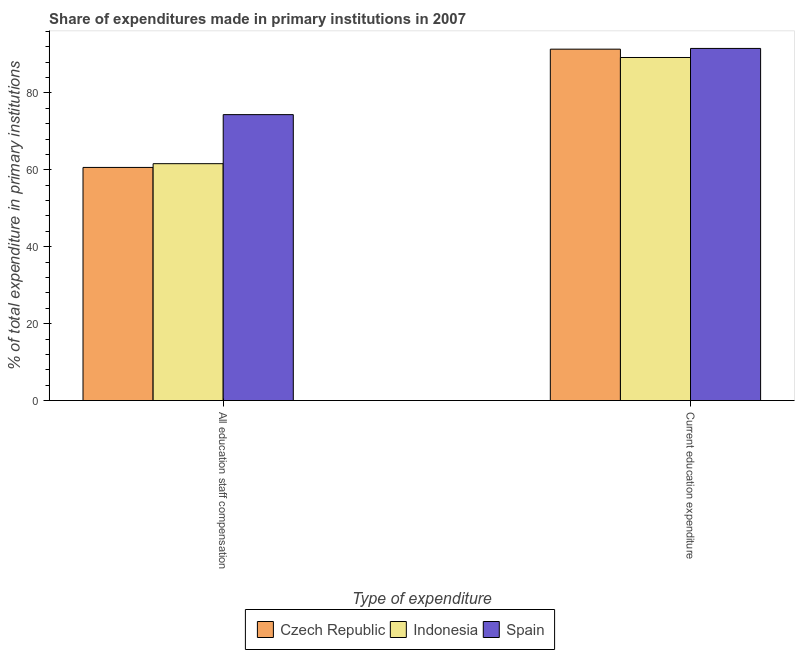Are the number of bars per tick equal to the number of legend labels?
Provide a succinct answer. Yes. How many bars are there on the 1st tick from the right?
Offer a very short reply. 3. What is the label of the 2nd group of bars from the left?
Give a very brief answer. Current education expenditure. What is the expenditure in staff compensation in Czech Republic?
Ensure brevity in your answer.  60.62. Across all countries, what is the maximum expenditure in education?
Provide a short and direct response. 91.57. Across all countries, what is the minimum expenditure in staff compensation?
Your answer should be very brief. 60.62. In which country was the expenditure in staff compensation maximum?
Ensure brevity in your answer.  Spain. In which country was the expenditure in staff compensation minimum?
Offer a very short reply. Czech Republic. What is the total expenditure in staff compensation in the graph?
Give a very brief answer. 196.58. What is the difference between the expenditure in staff compensation in Spain and that in Indonesia?
Your answer should be very brief. 12.75. What is the difference between the expenditure in education in Spain and the expenditure in staff compensation in Czech Republic?
Give a very brief answer. 30.94. What is the average expenditure in staff compensation per country?
Give a very brief answer. 65.53. What is the difference between the expenditure in staff compensation and expenditure in education in Czech Republic?
Your answer should be compact. -30.75. In how many countries, is the expenditure in education greater than 80 %?
Make the answer very short. 3. What is the ratio of the expenditure in staff compensation in Czech Republic to that in Indonesia?
Provide a short and direct response. 0.98. Is the expenditure in staff compensation in Czech Republic less than that in Spain?
Provide a short and direct response. Yes. In how many countries, is the expenditure in education greater than the average expenditure in education taken over all countries?
Provide a short and direct response. 2. How many bars are there?
Keep it short and to the point. 6. How many countries are there in the graph?
Your response must be concise. 3. Does the graph contain any zero values?
Offer a very short reply. No. How many legend labels are there?
Make the answer very short. 3. What is the title of the graph?
Your response must be concise. Share of expenditures made in primary institutions in 2007. Does "Suriname" appear as one of the legend labels in the graph?
Ensure brevity in your answer.  No. What is the label or title of the X-axis?
Ensure brevity in your answer.  Type of expenditure. What is the label or title of the Y-axis?
Ensure brevity in your answer.  % of total expenditure in primary institutions. What is the % of total expenditure in primary institutions in Czech Republic in All education staff compensation?
Keep it short and to the point. 60.62. What is the % of total expenditure in primary institutions of Indonesia in All education staff compensation?
Provide a short and direct response. 61.6. What is the % of total expenditure in primary institutions in Spain in All education staff compensation?
Provide a short and direct response. 74.35. What is the % of total expenditure in primary institutions in Czech Republic in Current education expenditure?
Provide a succinct answer. 91.38. What is the % of total expenditure in primary institutions in Indonesia in Current education expenditure?
Offer a terse response. 89.21. What is the % of total expenditure in primary institutions of Spain in Current education expenditure?
Make the answer very short. 91.57. Across all Type of expenditure, what is the maximum % of total expenditure in primary institutions in Czech Republic?
Keep it short and to the point. 91.38. Across all Type of expenditure, what is the maximum % of total expenditure in primary institutions of Indonesia?
Keep it short and to the point. 89.21. Across all Type of expenditure, what is the maximum % of total expenditure in primary institutions in Spain?
Keep it short and to the point. 91.57. Across all Type of expenditure, what is the minimum % of total expenditure in primary institutions in Czech Republic?
Give a very brief answer. 60.62. Across all Type of expenditure, what is the minimum % of total expenditure in primary institutions of Indonesia?
Make the answer very short. 61.6. Across all Type of expenditure, what is the minimum % of total expenditure in primary institutions of Spain?
Your answer should be very brief. 74.35. What is the total % of total expenditure in primary institutions in Czech Republic in the graph?
Your response must be concise. 152. What is the total % of total expenditure in primary institutions of Indonesia in the graph?
Give a very brief answer. 150.81. What is the total % of total expenditure in primary institutions of Spain in the graph?
Make the answer very short. 165.92. What is the difference between the % of total expenditure in primary institutions of Czech Republic in All education staff compensation and that in Current education expenditure?
Offer a terse response. -30.75. What is the difference between the % of total expenditure in primary institutions of Indonesia in All education staff compensation and that in Current education expenditure?
Your answer should be compact. -27.61. What is the difference between the % of total expenditure in primary institutions in Spain in All education staff compensation and that in Current education expenditure?
Ensure brevity in your answer.  -17.22. What is the difference between the % of total expenditure in primary institutions in Czech Republic in All education staff compensation and the % of total expenditure in primary institutions in Indonesia in Current education expenditure?
Offer a terse response. -28.59. What is the difference between the % of total expenditure in primary institutions of Czech Republic in All education staff compensation and the % of total expenditure in primary institutions of Spain in Current education expenditure?
Provide a short and direct response. -30.94. What is the difference between the % of total expenditure in primary institutions of Indonesia in All education staff compensation and the % of total expenditure in primary institutions of Spain in Current education expenditure?
Offer a terse response. -29.97. What is the average % of total expenditure in primary institutions of Czech Republic per Type of expenditure?
Your answer should be very brief. 76. What is the average % of total expenditure in primary institutions of Indonesia per Type of expenditure?
Ensure brevity in your answer.  75.41. What is the average % of total expenditure in primary institutions in Spain per Type of expenditure?
Ensure brevity in your answer.  82.96. What is the difference between the % of total expenditure in primary institutions in Czech Republic and % of total expenditure in primary institutions in Indonesia in All education staff compensation?
Your response must be concise. -0.98. What is the difference between the % of total expenditure in primary institutions in Czech Republic and % of total expenditure in primary institutions in Spain in All education staff compensation?
Your answer should be very brief. -13.73. What is the difference between the % of total expenditure in primary institutions in Indonesia and % of total expenditure in primary institutions in Spain in All education staff compensation?
Give a very brief answer. -12.75. What is the difference between the % of total expenditure in primary institutions of Czech Republic and % of total expenditure in primary institutions of Indonesia in Current education expenditure?
Your response must be concise. 2.17. What is the difference between the % of total expenditure in primary institutions in Czech Republic and % of total expenditure in primary institutions in Spain in Current education expenditure?
Ensure brevity in your answer.  -0.19. What is the difference between the % of total expenditure in primary institutions of Indonesia and % of total expenditure in primary institutions of Spain in Current education expenditure?
Your response must be concise. -2.36. What is the ratio of the % of total expenditure in primary institutions in Czech Republic in All education staff compensation to that in Current education expenditure?
Offer a very short reply. 0.66. What is the ratio of the % of total expenditure in primary institutions of Indonesia in All education staff compensation to that in Current education expenditure?
Your answer should be very brief. 0.69. What is the ratio of the % of total expenditure in primary institutions in Spain in All education staff compensation to that in Current education expenditure?
Your response must be concise. 0.81. What is the difference between the highest and the second highest % of total expenditure in primary institutions in Czech Republic?
Offer a terse response. 30.75. What is the difference between the highest and the second highest % of total expenditure in primary institutions in Indonesia?
Your answer should be very brief. 27.61. What is the difference between the highest and the second highest % of total expenditure in primary institutions of Spain?
Make the answer very short. 17.22. What is the difference between the highest and the lowest % of total expenditure in primary institutions in Czech Republic?
Give a very brief answer. 30.75. What is the difference between the highest and the lowest % of total expenditure in primary institutions of Indonesia?
Your answer should be very brief. 27.61. What is the difference between the highest and the lowest % of total expenditure in primary institutions of Spain?
Give a very brief answer. 17.22. 